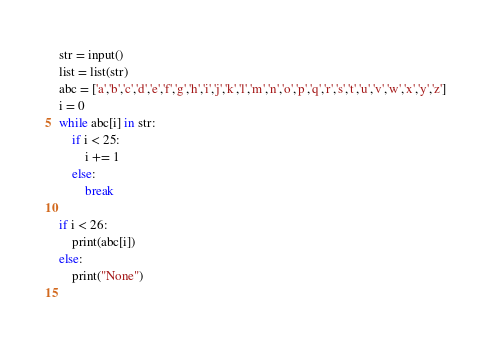Convert code to text. <code><loc_0><loc_0><loc_500><loc_500><_Python_>str = input()
list = list(str)
abc = ['a','b','c','d','e','f','g','h','i','j','k','l','m','n','o','p','q','r','s','t','u','v','w','x','y','z']
i = 0
while abc[i] in str:
    if i < 25:
        i += 1
    else:
        break

if i < 26:
    print(abc[i])
else:
    print("None")
    </code> 